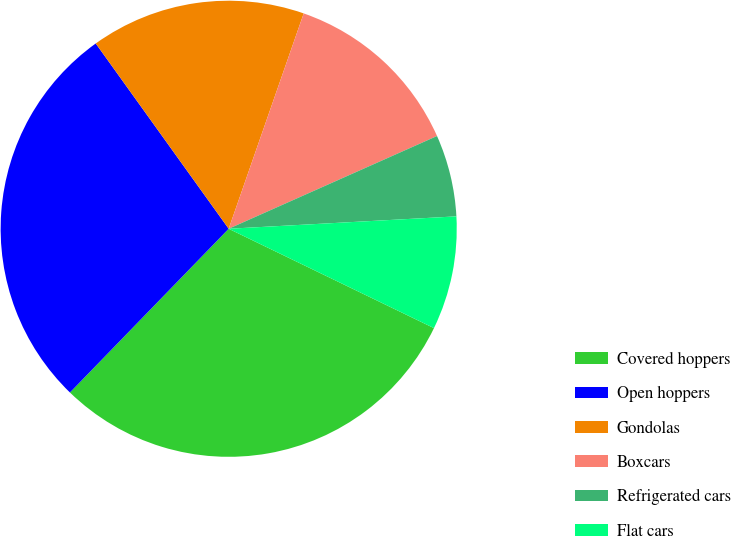Convert chart. <chart><loc_0><loc_0><loc_500><loc_500><pie_chart><fcel>Covered hoppers<fcel>Open hoppers<fcel>Gondolas<fcel>Boxcars<fcel>Refrigerated cars<fcel>Flat cars<nl><fcel>30.08%<fcel>27.84%<fcel>15.24%<fcel>13.0%<fcel>5.8%<fcel>8.04%<nl></chart> 